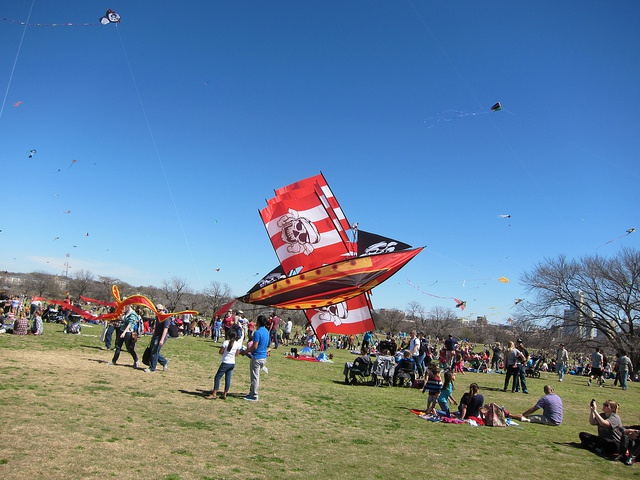Describe the objects in this image and their specific colors. I can see kite in blue, red, black, lavender, and salmon tones, people in blue, black, olive, gray, and maroon tones, people in blue, black, gray, and lightblue tones, people in blue, black, gray, olive, and darkgray tones, and people in blue, black, gray, darkgray, and lightgray tones in this image. 